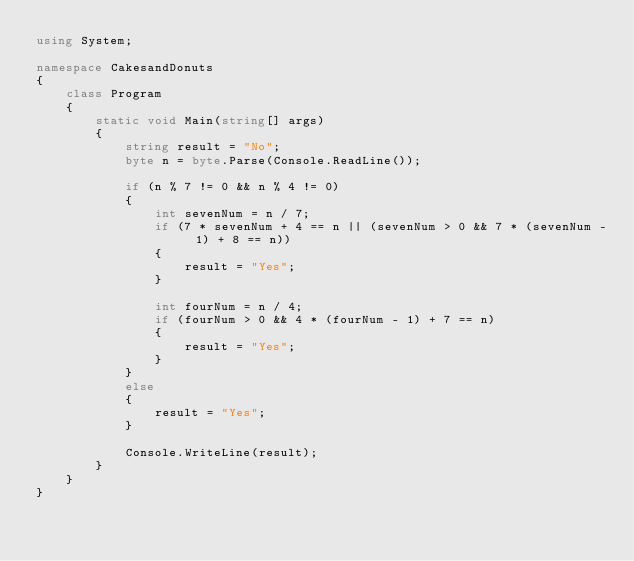Convert code to text. <code><loc_0><loc_0><loc_500><loc_500><_C#_>using System;

namespace CakesandDonuts
{
    class Program
    {
        static void Main(string[] args)
        {
            string result = "No";
            byte n = byte.Parse(Console.ReadLine());

            if (n % 7 != 0 && n % 4 != 0)
            {
                int sevenNum = n / 7;
                if (7 * sevenNum + 4 == n || (sevenNum > 0 && 7 * (sevenNum - 1) + 8 == n))
                {
                    result = "Yes";
                }

                int fourNum = n / 4;
                if (fourNum > 0 && 4 * (fourNum - 1) + 7 == n)
                {
                    result = "Yes";
                }
            }
            else
            {
                result = "Yes";
            }

            Console.WriteLine(result);
        }
    }
}</code> 